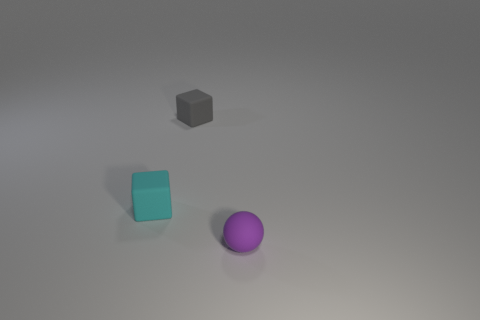Add 1 tiny purple rubber spheres. How many objects exist? 4 Subtract all blocks. How many objects are left? 1 Add 1 gray matte things. How many gray matte things are left? 2 Add 3 big blue rubber things. How many big blue rubber things exist? 3 Subtract 0 brown cylinders. How many objects are left? 3 Subtract all gray cylinders. Subtract all small gray rubber objects. How many objects are left? 2 